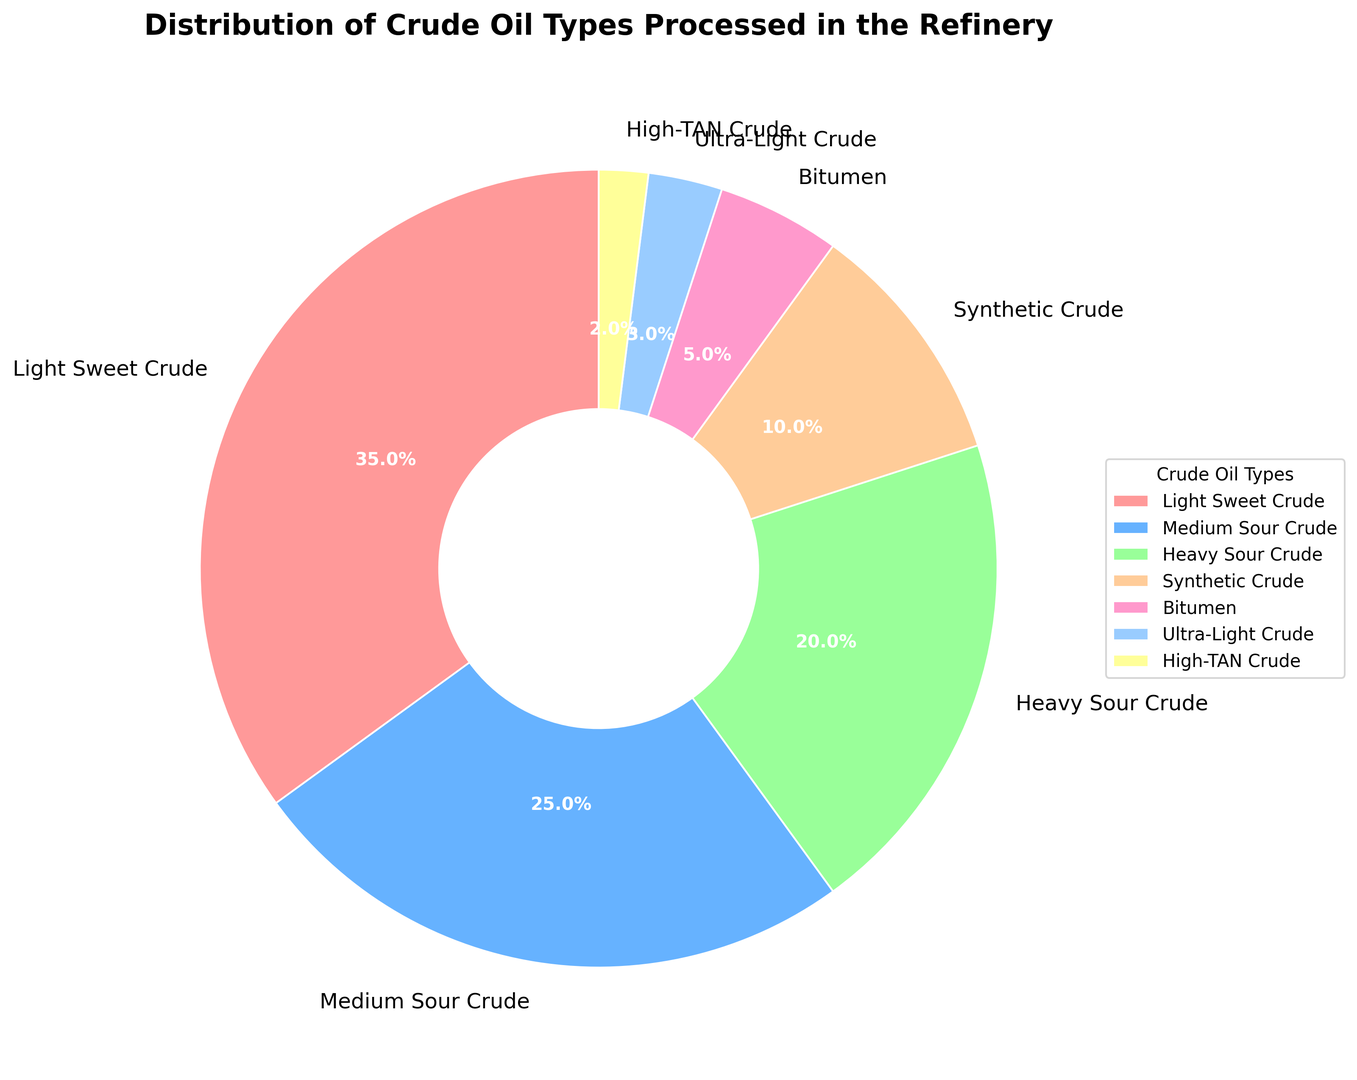What's the most processed type of crude oil in the refinery? The pie chart shows the largest segment labeled as "Light Sweet Crude" which has the highest percentage value of 35%.
Answer: Light Sweet Crude Which type of crude oil constitutes the least percentage of the refinery's processed oils? By identifying the smallest segment on the pie chart, it is labeled as "High-TAN Crude" with a percentage value of 2%.
Answer: High-TAN Crude What is the combined percentage of Medium Sour Crude and Ultra-Light Crude? The pie chart shows Medium Sour Crude at 25% and Ultra-Light Crude at 3%. Adding these values gives 25% + 3% = 28%.
Answer: 28% How does the percentage of processing Heavy Sour Crude compare to that of Bitumen? Heavy Sour Crude is shown to be 20% while Bitumen is 5%, indicating that Heavy Sour Crude is processed more than Bitumen. 20% is greater than 5%.
Answer: Heavy Sour Crude is processed more What percentage more of Synthetic Crude is processed compared to High-TAN Crude? Synthetic Crude is 10% while High-TAN Crude is 2%. The difference is 10% - 2% = 8%.
Answer: 8% What is the total percentage of all sour crudes (Medium Sour Crude and Heavy Sour Crude) processed in the refinery? The segments for Medium Sour Crude and Heavy Sour Crude are labeled 25% and 20% respectively. Their total is 25% + 20% = 45%.
Answer: 45% Which types of crude oil together make up more than half of the refinery's processed oils? Summing the percentages: Light Sweet Crude (35%) + Medium Sour Crude (25%) gives 60%, which is more than half. So, Light Sweet Crude and Medium Sour Crude together make up more than half.
Answer: Light Sweet Crude and Medium Sour Crude What is the difference in the percentage between the most and the least processed crude oil types? The most processed is Light Sweet Crude at 35%, and the least processed is High-TAN Crude at 2%. The difference is 35% - 2% = 33%.
Answer: 33% If the refinery decides to increase the processing of Ultra-Light Crude by 4%, what will the new percentage be? The current percentage of Ultra-Light Crude is 3%. If it is increased by 4%, the new percentage will be 3% + 4% = 7%.
Answer: 7% 